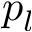Convert formula to latex. <formula><loc_0><loc_0><loc_500><loc_500>p _ { l }</formula> 